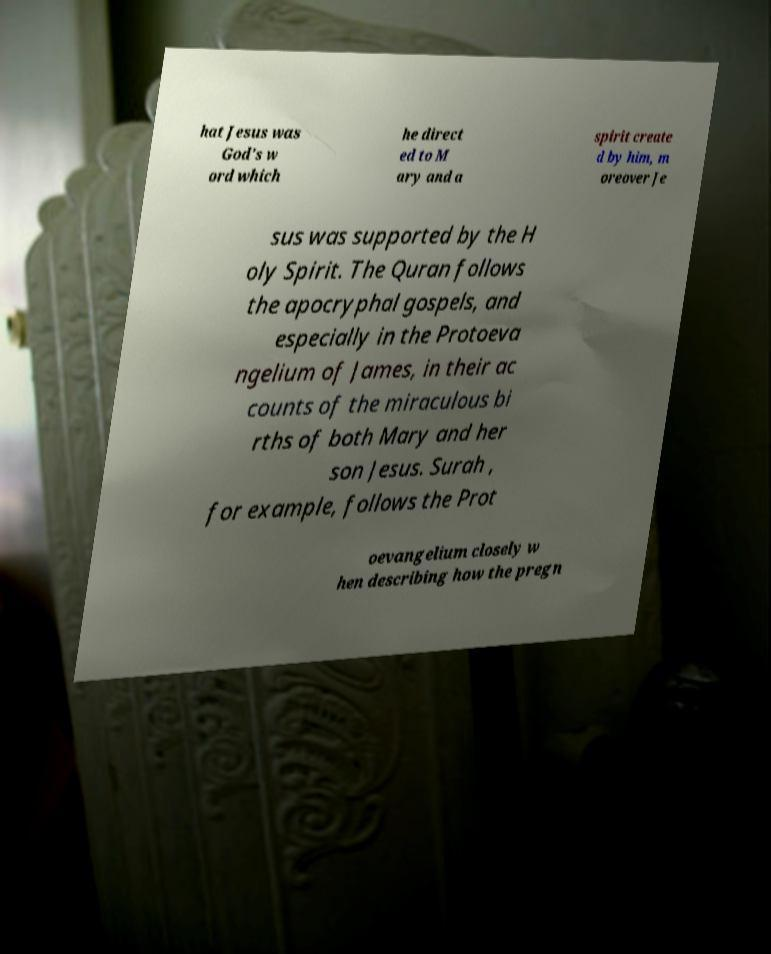There's text embedded in this image that I need extracted. Can you transcribe it verbatim? hat Jesus was God's w ord which he direct ed to M ary and a spirit create d by him, m oreover Je sus was supported by the H oly Spirit. The Quran follows the apocryphal gospels, and especially in the Protoeva ngelium of James, in their ac counts of the miraculous bi rths of both Mary and her son Jesus. Surah , for example, follows the Prot oevangelium closely w hen describing how the pregn 